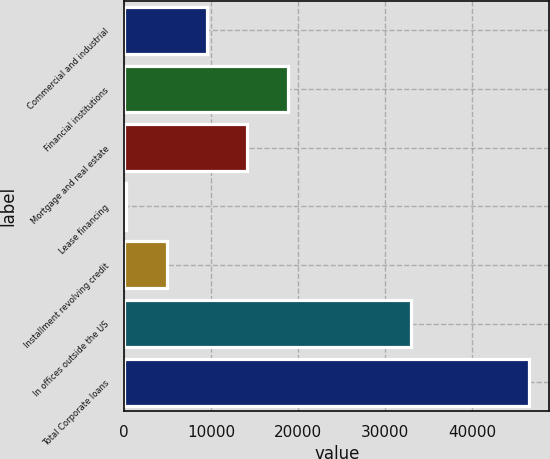<chart> <loc_0><loc_0><loc_500><loc_500><bar_chart><fcel>Commercial and industrial<fcel>Financial institutions<fcel>Mortgage and real estate<fcel>Lease financing<fcel>Installment revolving credit<fcel>In offices outside the US<fcel>Total Corporate loans<nl><fcel>9504.6<fcel>18762.2<fcel>14133.4<fcel>247<fcel>4875.8<fcel>32910<fcel>46535<nl></chart> 